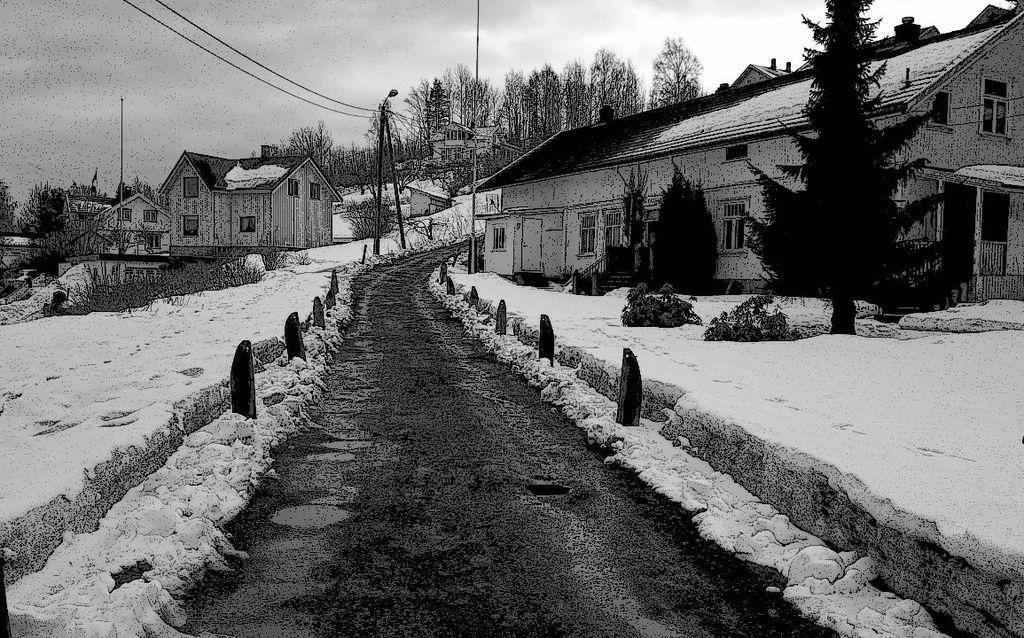What is the color scheme of the image? The image is black and white. What type of structures can be seen in the image? There are buildings in the image. What architectural features are visible on the buildings? There are windows visible in the image. What type of vegetation is present in the image? There are trees and plants in the image. What type of infrastructure is present in the image? Current poles are present in the image. What weather condition is depicted in the image? Snow is visible in the image. Can you tell me how many beetles are crawling on the current poles in the image? There are no beetles present in the image; it only shows buildings, windows, trees, plants, and current poles in a snowy environment. What type of pain is being experienced by the trees in the image? There is no indication of pain being experienced by the trees in the image; they are simply depicted as part of the landscape. 